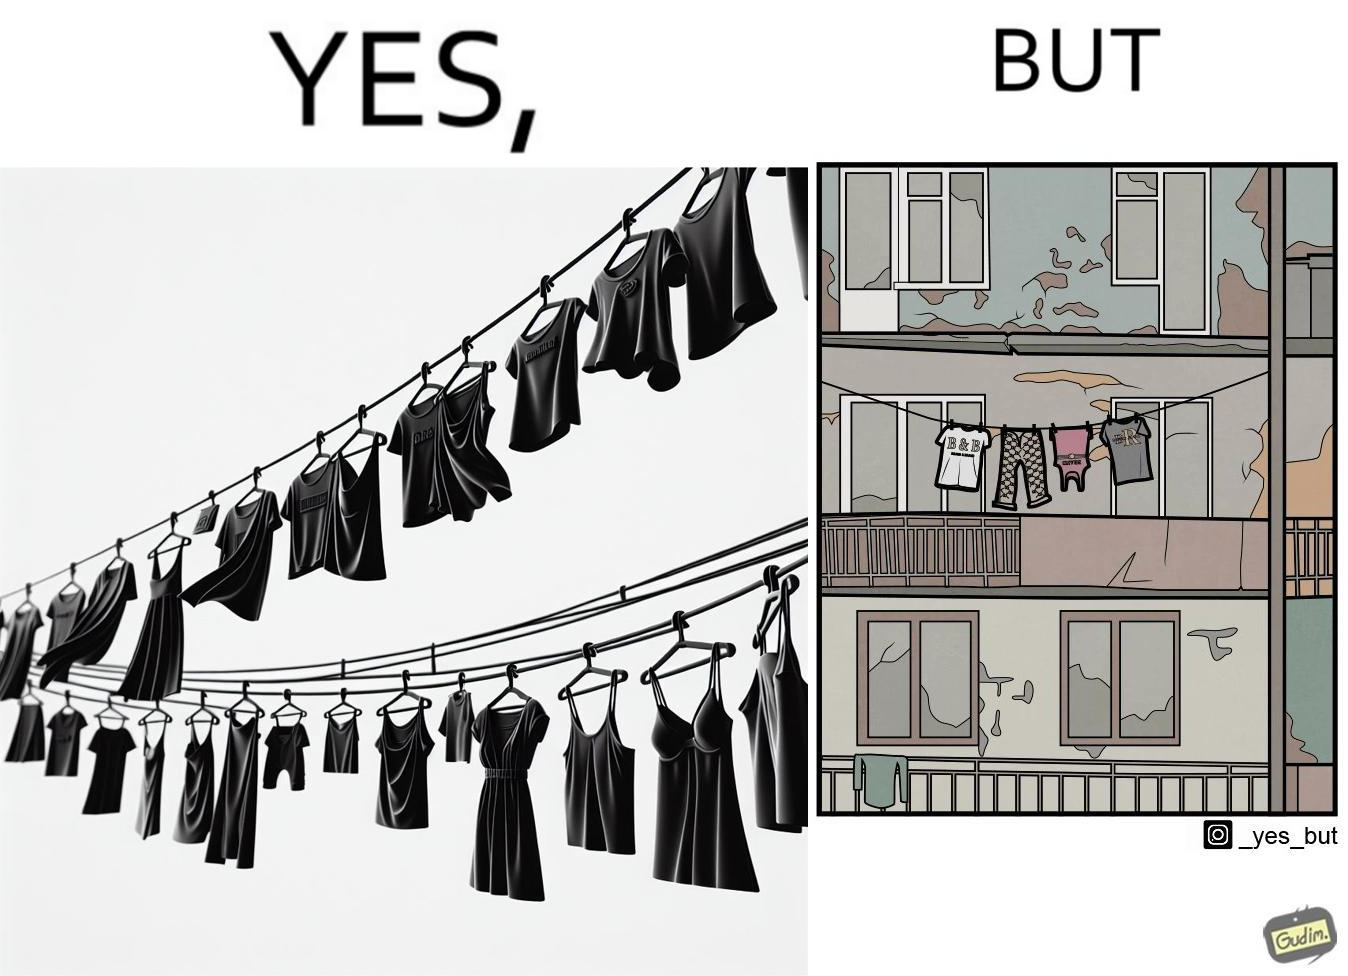Describe the content of this image. The image is ironic because although the clothes are of branded companies but they are hanging in very poor building. 